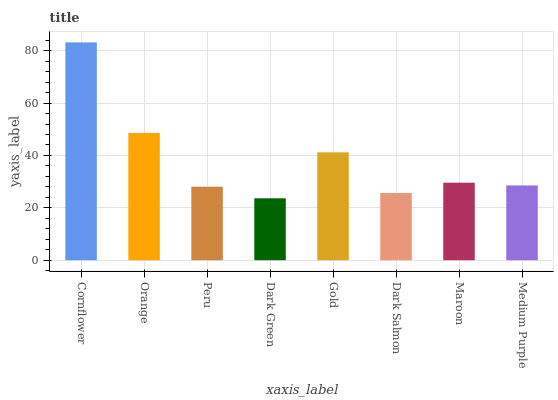Is Dark Green the minimum?
Answer yes or no. Yes. Is Cornflower the maximum?
Answer yes or no. Yes. Is Orange the minimum?
Answer yes or no. No. Is Orange the maximum?
Answer yes or no. No. Is Cornflower greater than Orange?
Answer yes or no. Yes. Is Orange less than Cornflower?
Answer yes or no. Yes. Is Orange greater than Cornflower?
Answer yes or no. No. Is Cornflower less than Orange?
Answer yes or no. No. Is Maroon the high median?
Answer yes or no. Yes. Is Medium Purple the low median?
Answer yes or no. Yes. Is Peru the high median?
Answer yes or no. No. Is Maroon the low median?
Answer yes or no. No. 